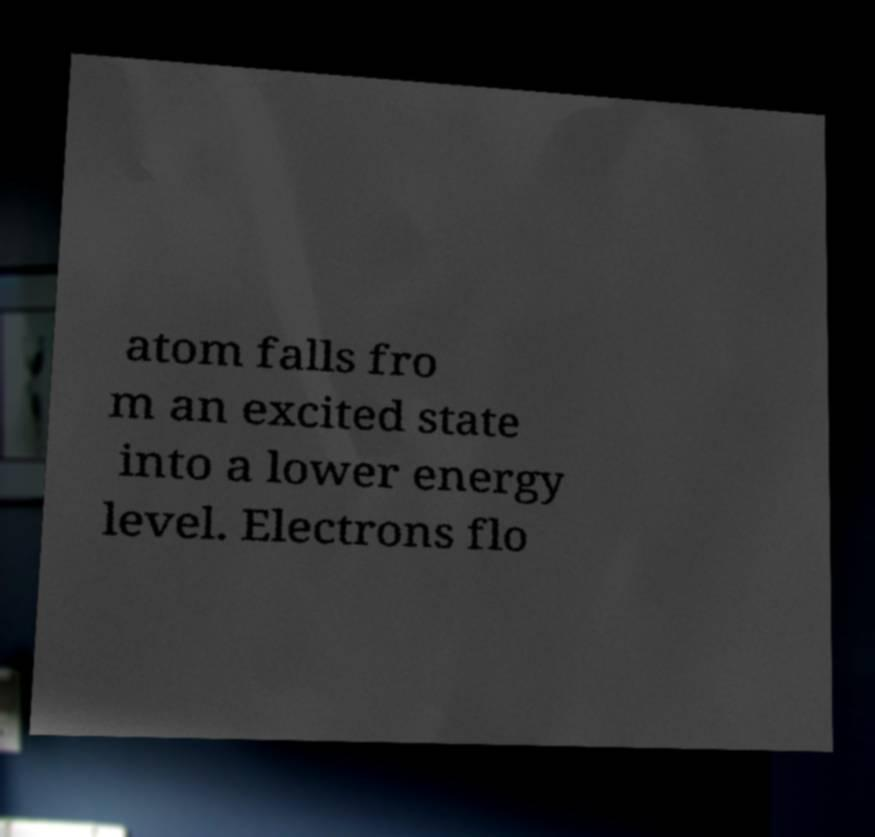Please identify and transcribe the text found in this image. atom falls fro m an excited state into a lower energy level. Electrons flo 